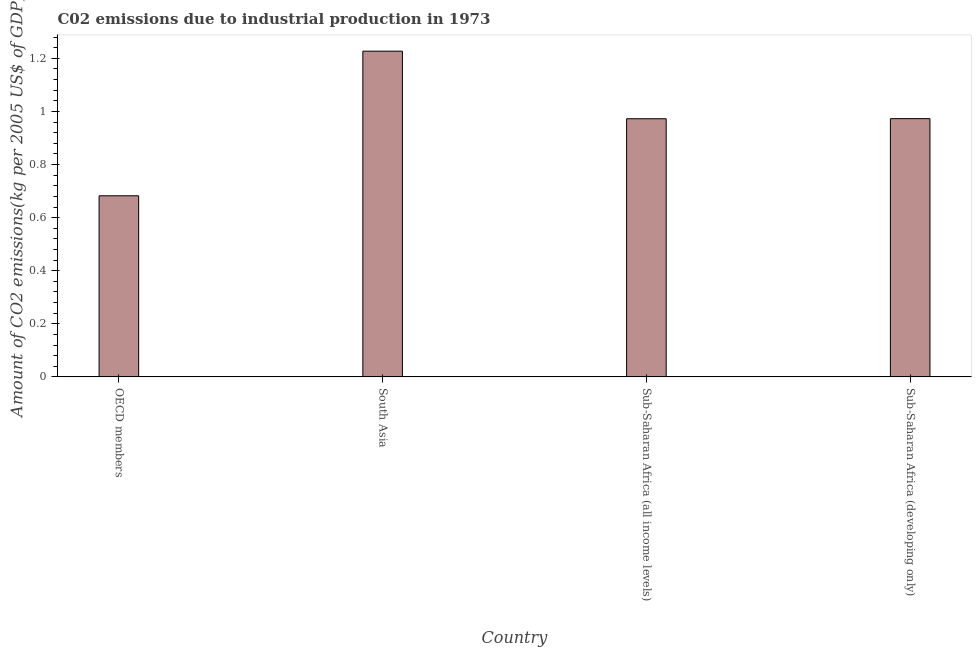Does the graph contain any zero values?
Give a very brief answer. No. Does the graph contain grids?
Make the answer very short. No. What is the title of the graph?
Your answer should be compact. C02 emissions due to industrial production in 1973. What is the label or title of the Y-axis?
Provide a short and direct response. Amount of CO2 emissions(kg per 2005 US$ of GDP). What is the amount of co2 emissions in Sub-Saharan Africa (all income levels)?
Ensure brevity in your answer.  0.97. Across all countries, what is the maximum amount of co2 emissions?
Make the answer very short. 1.23. Across all countries, what is the minimum amount of co2 emissions?
Ensure brevity in your answer.  0.68. In which country was the amount of co2 emissions maximum?
Make the answer very short. South Asia. In which country was the amount of co2 emissions minimum?
Offer a terse response. OECD members. What is the sum of the amount of co2 emissions?
Offer a very short reply. 3.85. What is the difference between the amount of co2 emissions in South Asia and Sub-Saharan Africa (all income levels)?
Keep it short and to the point. 0.26. What is the average amount of co2 emissions per country?
Give a very brief answer. 0.96. What is the median amount of co2 emissions?
Make the answer very short. 0.97. In how many countries, is the amount of co2 emissions greater than 0.24 kg per 2005 US$ of GDP?
Ensure brevity in your answer.  4. What is the ratio of the amount of co2 emissions in Sub-Saharan Africa (all income levels) to that in Sub-Saharan Africa (developing only)?
Keep it short and to the point. 1. Is the amount of co2 emissions in OECD members less than that in Sub-Saharan Africa (all income levels)?
Provide a short and direct response. Yes. Is the difference between the amount of co2 emissions in OECD members and Sub-Saharan Africa (all income levels) greater than the difference between any two countries?
Ensure brevity in your answer.  No. What is the difference between the highest and the second highest amount of co2 emissions?
Offer a terse response. 0.25. Is the sum of the amount of co2 emissions in South Asia and Sub-Saharan Africa (all income levels) greater than the maximum amount of co2 emissions across all countries?
Provide a short and direct response. Yes. What is the difference between the highest and the lowest amount of co2 emissions?
Keep it short and to the point. 0.54. In how many countries, is the amount of co2 emissions greater than the average amount of co2 emissions taken over all countries?
Make the answer very short. 3. How many bars are there?
Your response must be concise. 4. How many countries are there in the graph?
Offer a terse response. 4. What is the difference between two consecutive major ticks on the Y-axis?
Keep it short and to the point. 0.2. What is the Amount of CO2 emissions(kg per 2005 US$ of GDP) of OECD members?
Your response must be concise. 0.68. What is the Amount of CO2 emissions(kg per 2005 US$ of GDP) in South Asia?
Offer a terse response. 1.23. What is the Amount of CO2 emissions(kg per 2005 US$ of GDP) in Sub-Saharan Africa (all income levels)?
Make the answer very short. 0.97. What is the Amount of CO2 emissions(kg per 2005 US$ of GDP) of Sub-Saharan Africa (developing only)?
Provide a short and direct response. 0.97. What is the difference between the Amount of CO2 emissions(kg per 2005 US$ of GDP) in OECD members and South Asia?
Offer a terse response. -0.54. What is the difference between the Amount of CO2 emissions(kg per 2005 US$ of GDP) in OECD members and Sub-Saharan Africa (all income levels)?
Provide a succinct answer. -0.29. What is the difference between the Amount of CO2 emissions(kg per 2005 US$ of GDP) in OECD members and Sub-Saharan Africa (developing only)?
Ensure brevity in your answer.  -0.29. What is the difference between the Amount of CO2 emissions(kg per 2005 US$ of GDP) in South Asia and Sub-Saharan Africa (all income levels)?
Give a very brief answer. 0.25. What is the difference between the Amount of CO2 emissions(kg per 2005 US$ of GDP) in South Asia and Sub-Saharan Africa (developing only)?
Your answer should be very brief. 0.25. What is the difference between the Amount of CO2 emissions(kg per 2005 US$ of GDP) in Sub-Saharan Africa (all income levels) and Sub-Saharan Africa (developing only)?
Make the answer very short. -0. What is the ratio of the Amount of CO2 emissions(kg per 2005 US$ of GDP) in OECD members to that in South Asia?
Make the answer very short. 0.56. What is the ratio of the Amount of CO2 emissions(kg per 2005 US$ of GDP) in OECD members to that in Sub-Saharan Africa (all income levels)?
Offer a very short reply. 0.7. What is the ratio of the Amount of CO2 emissions(kg per 2005 US$ of GDP) in OECD members to that in Sub-Saharan Africa (developing only)?
Your answer should be compact. 0.7. What is the ratio of the Amount of CO2 emissions(kg per 2005 US$ of GDP) in South Asia to that in Sub-Saharan Africa (all income levels)?
Your answer should be very brief. 1.26. What is the ratio of the Amount of CO2 emissions(kg per 2005 US$ of GDP) in South Asia to that in Sub-Saharan Africa (developing only)?
Ensure brevity in your answer.  1.26. What is the ratio of the Amount of CO2 emissions(kg per 2005 US$ of GDP) in Sub-Saharan Africa (all income levels) to that in Sub-Saharan Africa (developing only)?
Provide a succinct answer. 1. 